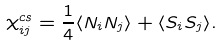Convert formula to latex. <formula><loc_0><loc_0><loc_500><loc_500>\chi _ { i j } ^ { c s } = \frac { 1 } { 4 } \langle N _ { i } N _ { j } \rangle + \langle { S } _ { i } { S } _ { j } \rangle .</formula> 